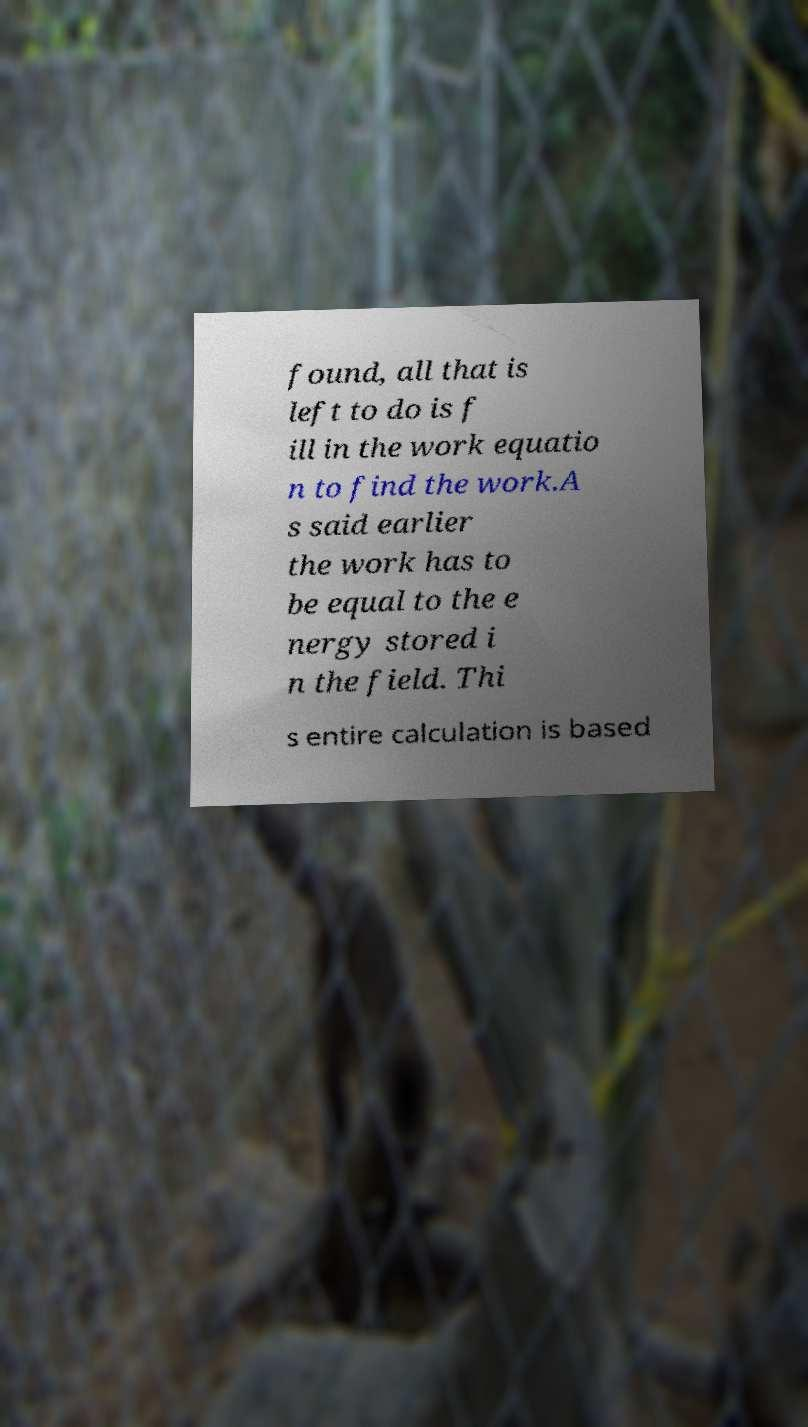For documentation purposes, I need the text within this image transcribed. Could you provide that? found, all that is left to do is f ill in the work equatio n to find the work.A s said earlier the work has to be equal to the e nergy stored i n the field. Thi s entire calculation is based 